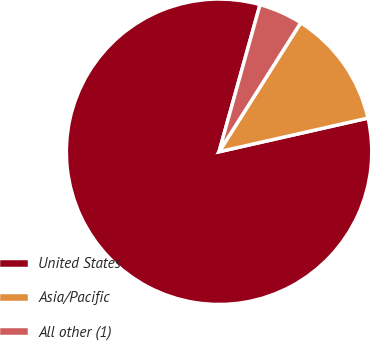Convert chart to OTSL. <chart><loc_0><loc_0><loc_500><loc_500><pie_chart><fcel>United States<fcel>Asia/Pacific<fcel>All other (1)<nl><fcel>82.87%<fcel>12.48%<fcel>4.66%<nl></chart> 